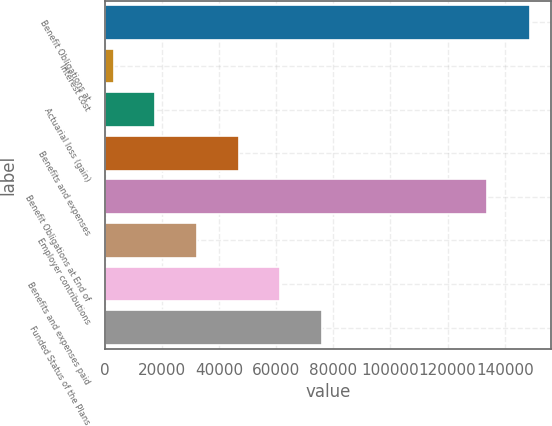<chart> <loc_0><loc_0><loc_500><loc_500><bar_chart><fcel>Benefit Obligations at<fcel>Interest cost<fcel>Actuarial loss (gain)<fcel>Benefits and expenses<fcel>Benefit Obligations at End of<fcel>Employer contributions<fcel>Benefits and expenses paid<fcel>Funded Status of the Plans<nl><fcel>148848<fcel>3255<fcel>17814.3<fcel>46932.9<fcel>133672<fcel>32373.6<fcel>61492.2<fcel>76051.5<nl></chart> 